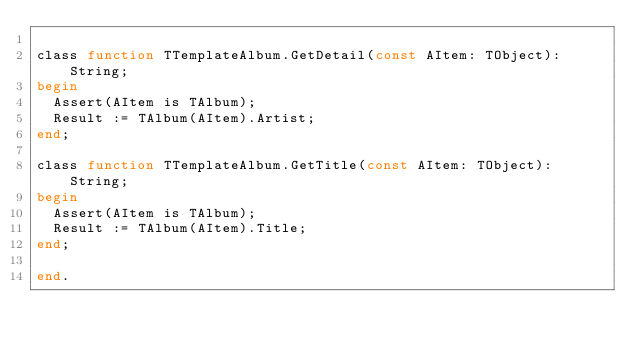<code> <loc_0><loc_0><loc_500><loc_500><_Pascal_>
class function TTemplateAlbum.GetDetail(const AItem: TObject): String;
begin
  Assert(AItem is TAlbum);
  Result := TAlbum(AItem).Artist;
end;

class function TTemplateAlbum.GetTitle(const AItem: TObject): String;
begin
  Assert(AItem is TAlbum);
  Result := TAlbum(AItem).Title;
end;

end.
</code> 